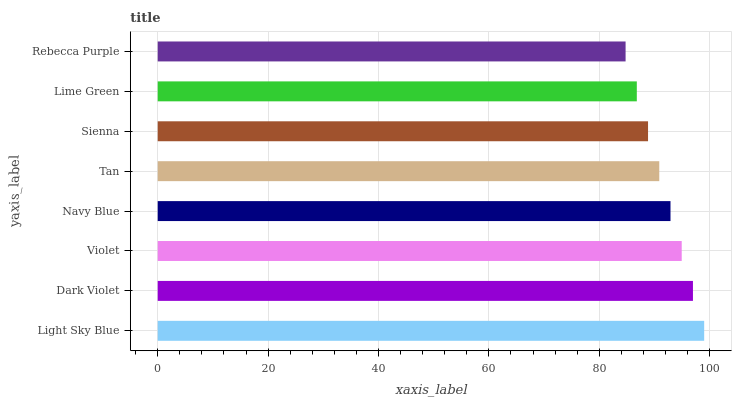Is Rebecca Purple the minimum?
Answer yes or no. Yes. Is Light Sky Blue the maximum?
Answer yes or no. Yes. Is Dark Violet the minimum?
Answer yes or no. No. Is Dark Violet the maximum?
Answer yes or no. No. Is Light Sky Blue greater than Dark Violet?
Answer yes or no. Yes. Is Dark Violet less than Light Sky Blue?
Answer yes or no. Yes. Is Dark Violet greater than Light Sky Blue?
Answer yes or no. No. Is Light Sky Blue less than Dark Violet?
Answer yes or no. No. Is Navy Blue the high median?
Answer yes or no. Yes. Is Tan the low median?
Answer yes or no. Yes. Is Sienna the high median?
Answer yes or no. No. Is Violet the low median?
Answer yes or no. No. 